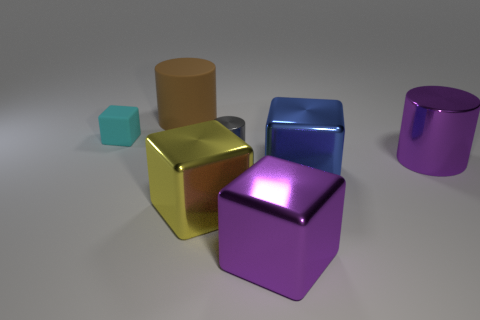Subtract all big purple cylinders. How many cylinders are left? 2 Add 1 cyan cubes. How many objects exist? 8 Subtract all yellow blocks. How many blocks are left? 3 Subtract all yellow cubes. Subtract all purple cylinders. How many cubes are left? 3 Subtract 0 blue cylinders. How many objects are left? 7 Subtract all blocks. How many objects are left? 3 Subtract all tiny green shiny blocks. Subtract all large yellow things. How many objects are left? 6 Add 5 big metallic objects. How many big metallic objects are left? 9 Add 7 large shiny cylinders. How many large shiny cylinders exist? 8 